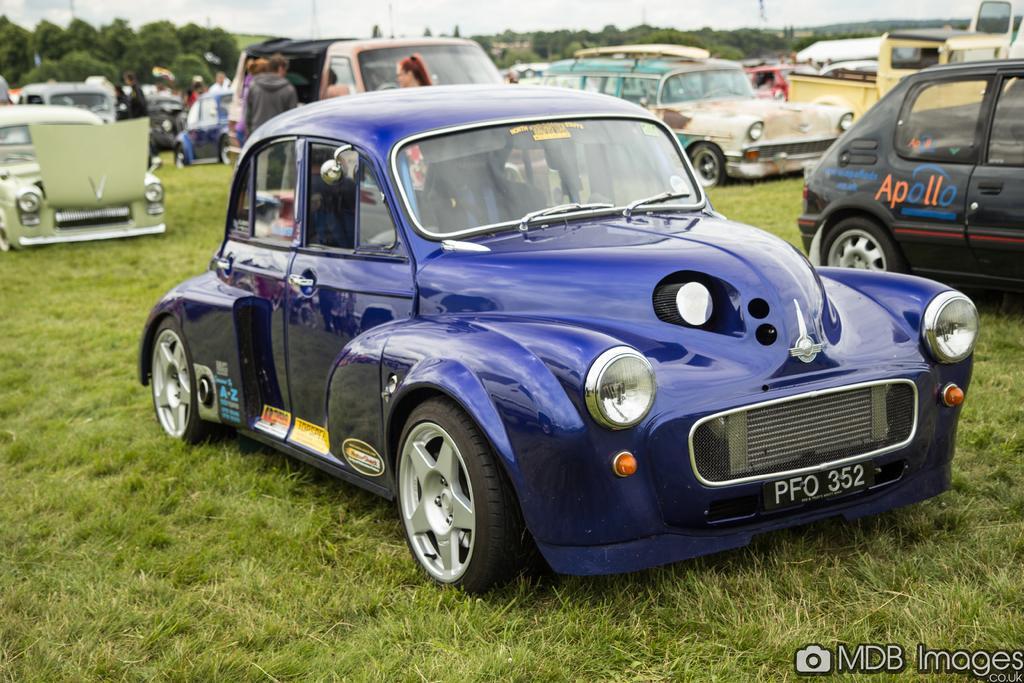Could you give a brief overview of what you see in this image? This picture is clicked outside. In the center we can see the group of vehicles seems to be parked on the ground and we can see the group of persons and the ground is covered with the green grass. In the background there is a sky and we can see the trees. In the bottom right corner there is a text on the image. 